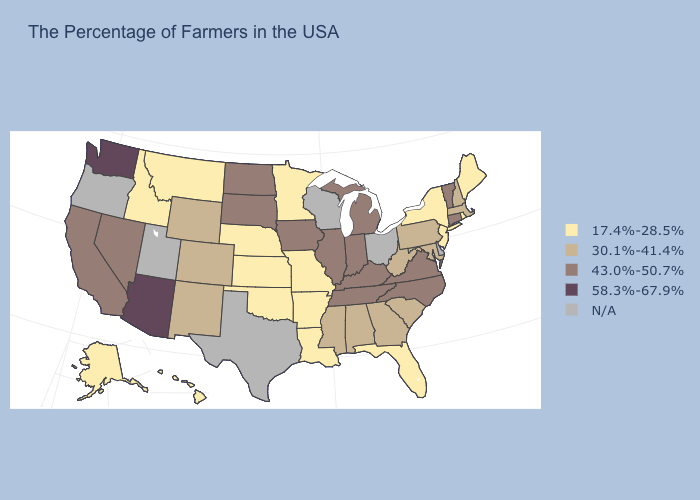Does Indiana have the highest value in the MidWest?
Quick response, please. Yes. Name the states that have a value in the range 58.3%-67.9%?
Quick response, please. Arizona, Washington. Among the states that border New Jersey , which have the lowest value?
Answer briefly. New York. What is the value of Maine?
Write a very short answer. 17.4%-28.5%. How many symbols are there in the legend?
Write a very short answer. 5. Name the states that have a value in the range 43.0%-50.7%?
Write a very short answer. Vermont, Connecticut, Virginia, North Carolina, Michigan, Kentucky, Indiana, Tennessee, Illinois, Iowa, South Dakota, North Dakota, Nevada, California. How many symbols are there in the legend?
Be succinct. 5. Does Washington have the highest value in the USA?
Be succinct. Yes. What is the highest value in states that border Idaho?
Quick response, please. 58.3%-67.9%. Does Mississippi have the highest value in the South?
Keep it brief. No. What is the value of Alabama?
Be succinct. 30.1%-41.4%. Which states have the lowest value in the West?
Keep it brief. Montana, Idaho, Alaska, Hawaii. Name the states that have a value in the range 17.4%-28.5%?
Concise answer only. Maine, Rhode Island, New York, New Jersey, Florida, Louisiana, Missouri, Arkansas, Minnesota, Kansas, Nebraska, Oklahoma, Montana, Idaho, Alaska, Hawaii. 